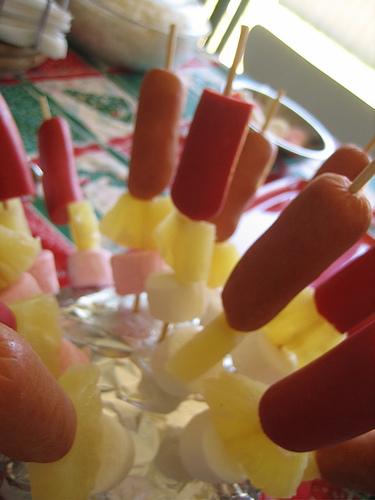Are there marshmallows on the sticks?
Be succinct. Yes. What is the origin of this appetizer?
Answer briefly. Tree, pig, confectionary. Are there pineapples?
Give a very brief answer. Yes. 